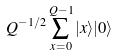Convert formula to latex. <formula><loc_0><loc_0><loc_500><loc_500>Q ^ { - 1 / 2 } \sum _ { x = 0 } ^ { Q - 1 } | x \rangle | 0 \rangle</formula> 